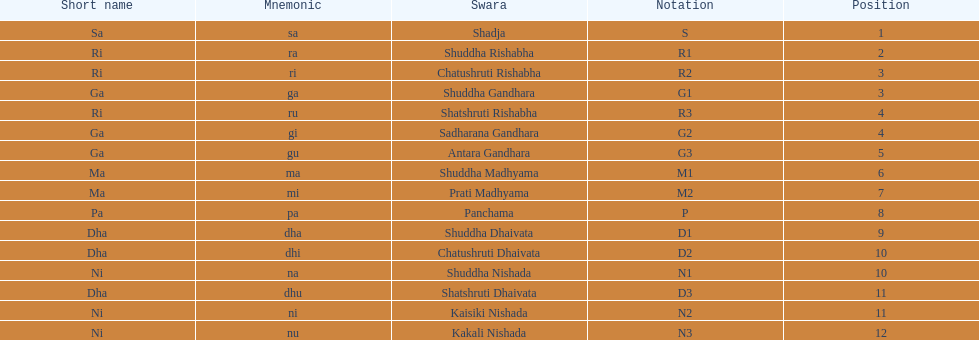How many swara typically have short names that start with the letter d or g on average? 6. 